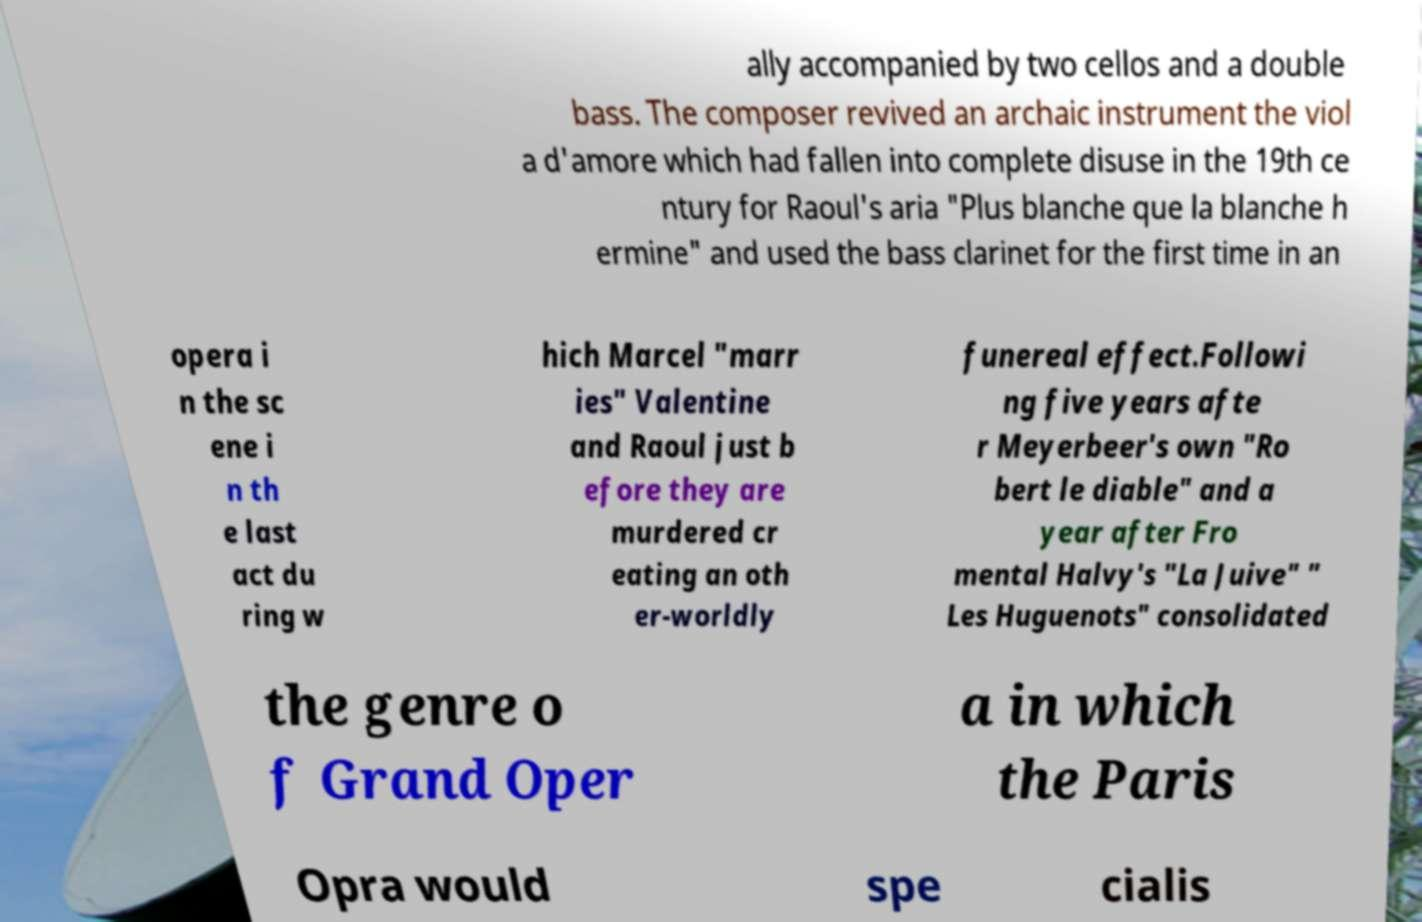For documentation purposes, I need the text within this image transcribed. Could you provide that? ally accompanied by two cellos and a double bass. The composer revived an archaic instrument the viol a d'amore which had fallen into complete disuse in the 19th ce ntury for Raoul's aria "Plus blanche que la blanche h ermine" and used the bass clarinet for the first time in an opera i n the sc ene i n th e last act du ring w hich Marcel "marr ies" Valentine and Raoul just b efore they are murdered cr eating an oth er-worldly funereal effect.Followi ng five years afte r Meyerbeer's own "Ro bert le diable" and a year after Fro mental Halvy's "La Juive" " Les Huguenots" consolidated the genre o f Grand Oper a in which the Paris Opra would spe cialis 